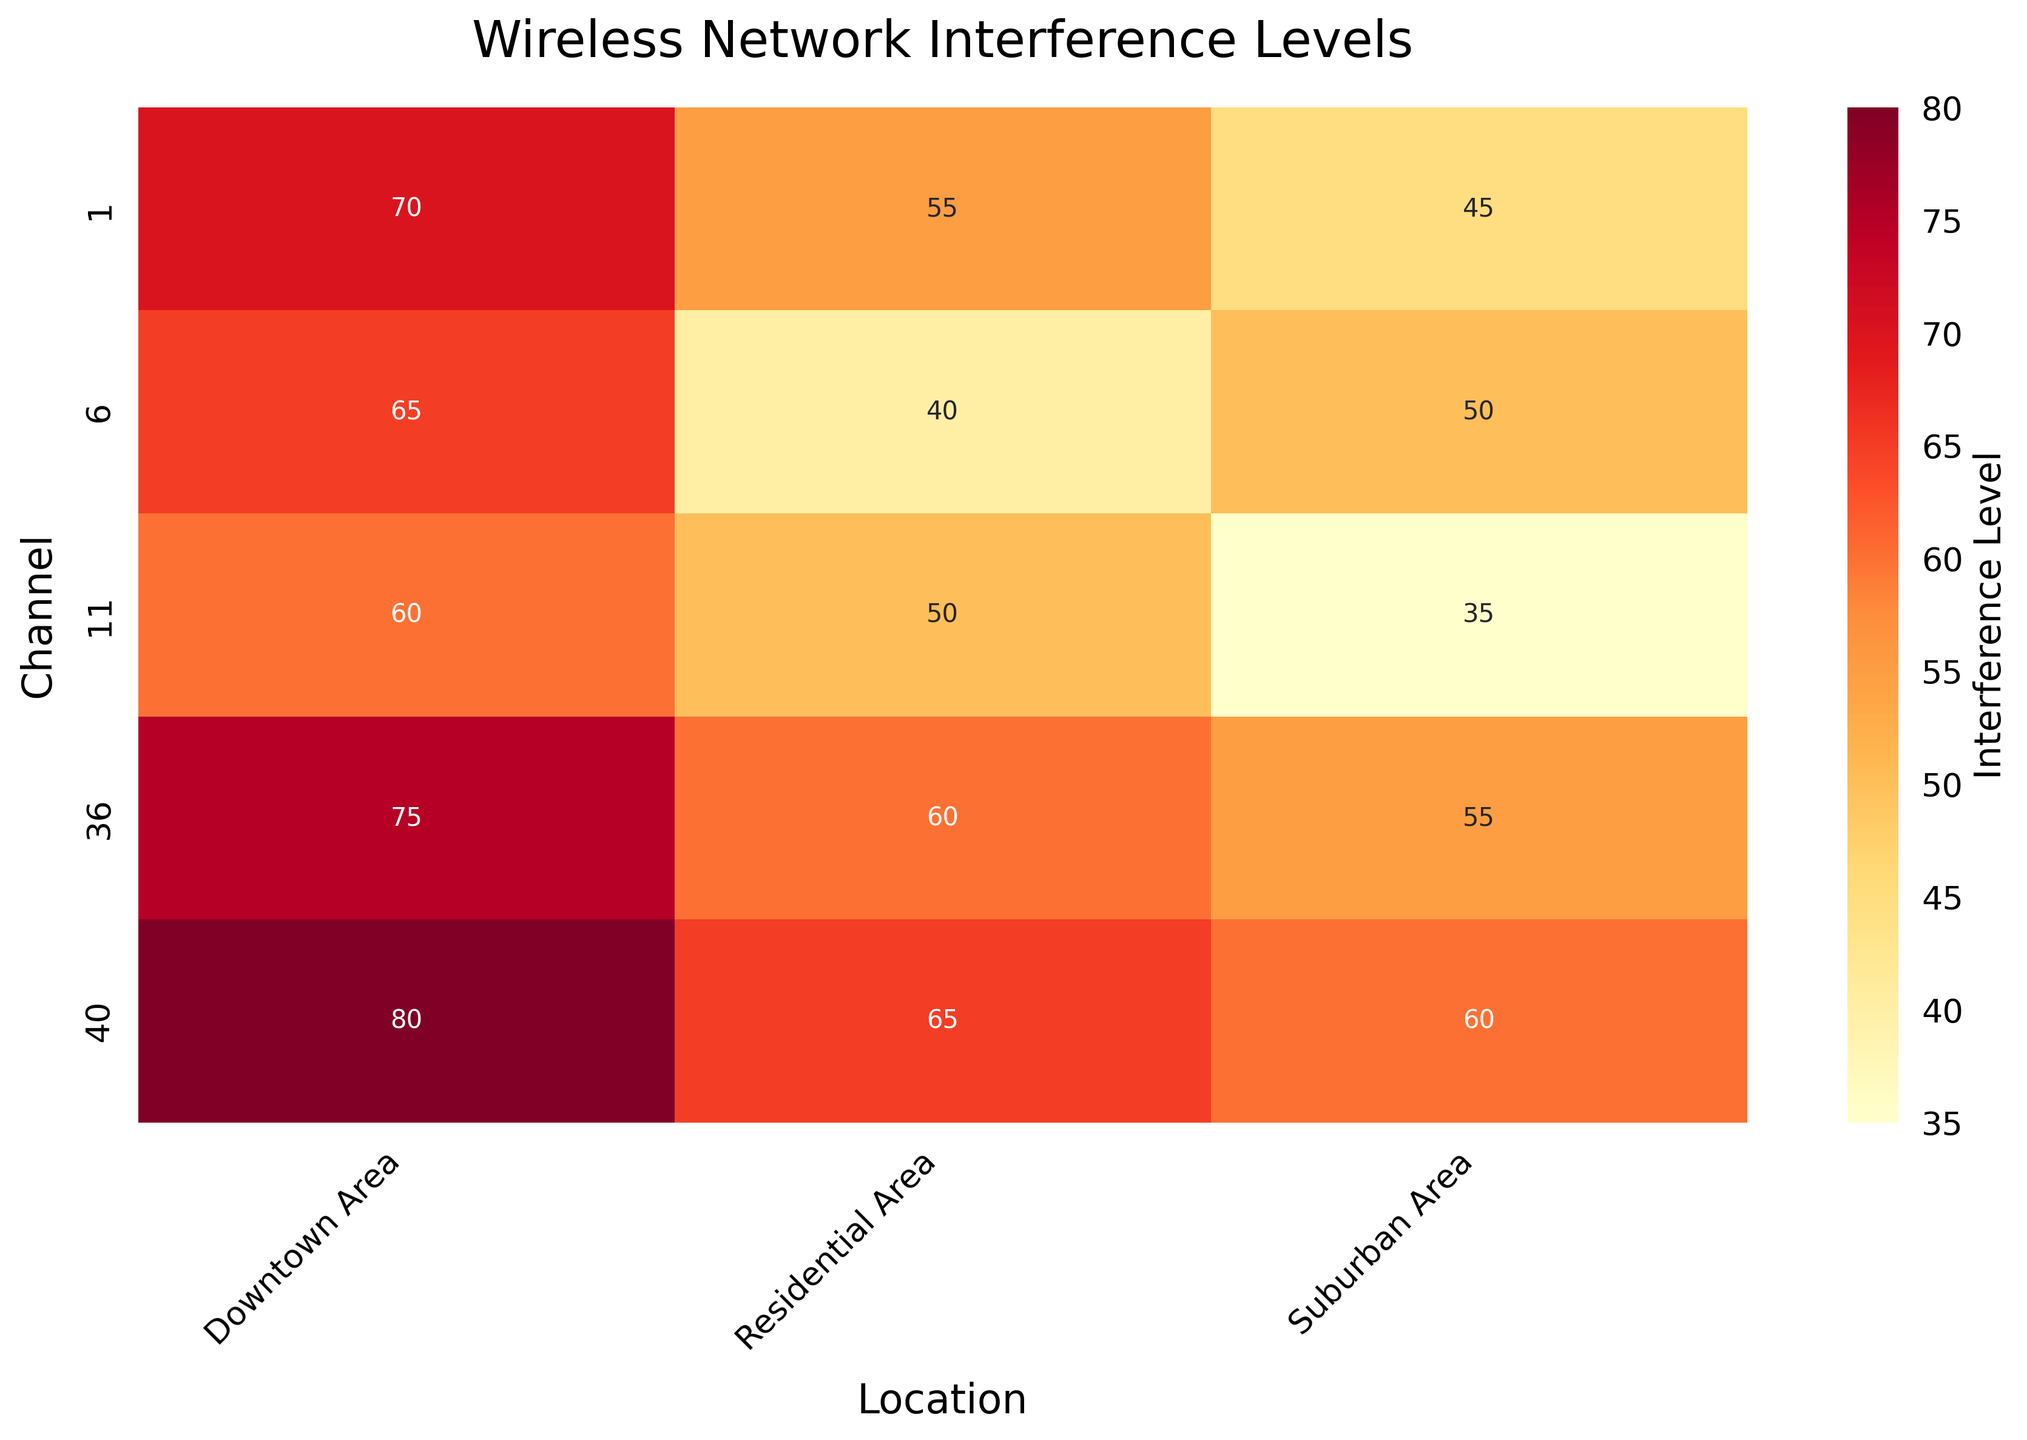What's the title of the heatmap? The title is displayed at the top of the heatmap in larger font to indicate what the heatmap represents.
Answer: Wireless Network Interference Levels What channels are displayed on the y-axis? The y-axis lists the different wireless channels covered in the dataset which ranges from lower to higher frequency channels. The channels are 1, 6, 11, 36, and 40.
Answer: 1, 6, 11, 36, 40 What location has the lowest interference level on channel 6? By examining the cells corresponding to channel 6, we can compare the interference levels across Downtown Area, Suburban Area, and Residential Area. Suburban Area has the lowest value.
Answer: Suburban Area Which area has the highest interference level across all channels? By looking for the darkest (deepest color) cell in the heatmap, we identify the highest interference level cell which is in the Downtown Area on channel 40 with a value of 80.
Answer: Downtown Area How does the interference level for channel 1 in the Downtown Area compare to the Suburban Area? Compare the values in the heatmap for channel 1 between Downtown Area and Suburban Area. The interference level in the Downtown Area (70) is higher than in the Suburban Area (45).
Answer: Higher Is there any area with consistent interference levels across different channels? Check for cells in the same row that have close or identical interference values across the heatmap. The Suburban Area has values 45, 50, 35, 55, and 60, showing somewhat consistent mid-range interference levels across the channels.
Answer: Suburban Area Which channel has the lowest interference level in the Residential Area? By comparing the values for all channels in the Residential Area column, channel 6 is the one with the lowest value (40).
Answer: 6 What is the average interference level for all locations on channel 11? Add the values on channel 11 and divide by the number of locations: (60 + 35 + 50) / 3 = 145 / 3 = 48.33
Answer: 48.33 Which channel shows the highest variation in interference levels across different locations? Calculate the range (difference between highest and lowest value) for each channel. Channel 11 has the highest range (60 - 35 = 25), indicating the greatest variation.
Answer: 11 What trend can be observed in the interference levels in the Downtown Area across increasing channels? Observe the values for the Downtown Area as the channel number increases: 70, 65, 60, 75, 80. There's a general trend that levels decrease slightly at first but then increase.
Answer: Decreases then increases 